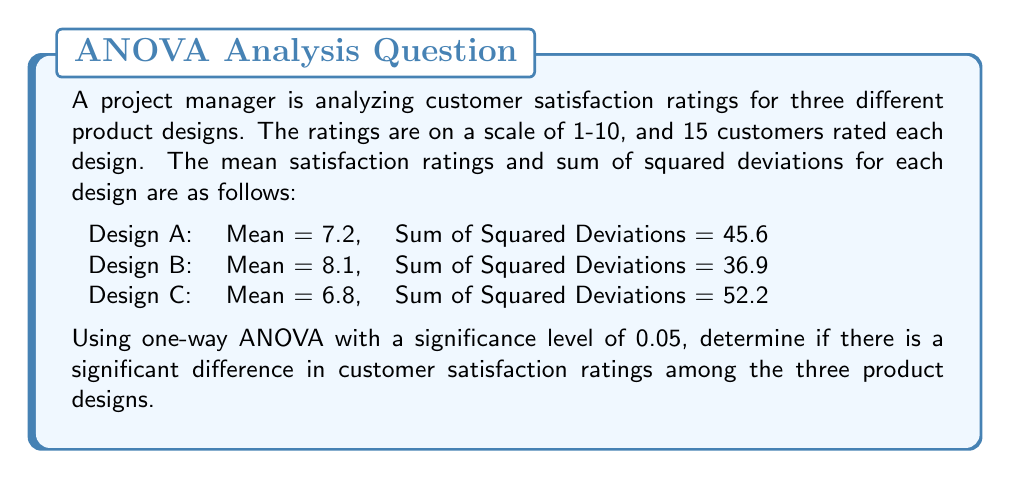Teach me how to tackle this problem. To determine if there's a significant difference in customer satisfaction ratings among the three product designs, we'll use one-way ANOVA. Let's follow these steps:

1. Calculate the total sum of squares (SST):
   $$SST = SSB + SSW$$
   Where SSB is the sum of squares between groups and SSW is the sum of squares within groups.

2. Calculate SSW:
   $$SSW = 45.6 + 36.9 + 52.2 = 134.7$$

3. Calculate the total mean:
   $$\bar{X} = \frac{(7.2 \times 15) + (8.1 \times 15) + (6.8 \times 15)}{45} = 7.37$$

4. Calculate SSB:
   $$SSB = 15[(7.2 - 7.37)^2 + (8.1 - 7.37)^2 + (6.8 - 7.37)^2] = 15.21$$

5. Calculate SST:
   $$SST = SSB + SSW = 15.21 + 134.7 = 149.91$$

6. Calculate degrees of freedom:
   $$df_{between} = k - 1 = 3 - 1 = 2$$
   $$df_{within} = N - k = 45 - 3 = 42$$
   $$df_{total} = N - 1 = 45 - 1 = 44$$

7. Calculate mean squares:
   $$MS_{between} = \frac{SSB}{df_{between}} = \frac{15.21}{2} = 7.605$$
   $$MS_{within} = \frac{SSW}{df_{within}} = \frac{134.7}{42} = 3.207$$

8. Calculate F-statistic:
   $$F = \frac{MS_{between}}{MS_{within}} = \frac{7.605}{3.207} = 2.371$$

9. Find the critical F-value:
   For $\alpha = 0.05$, $df_{between} = 2$, and $df_{within} = 42$, the critical F-value is approximately 3.22.

10. Compare F-statistic to critical F-value:
    Since 2.371 < 3.22, we fail to reject the null hypothesis.
Answer: There is not enough evidence to conclude that there is a significant difference in customer satisfaction ratings among the three product designs at the 0.05 significance level (F(2, 42) = 2.371, p > 0.05). 